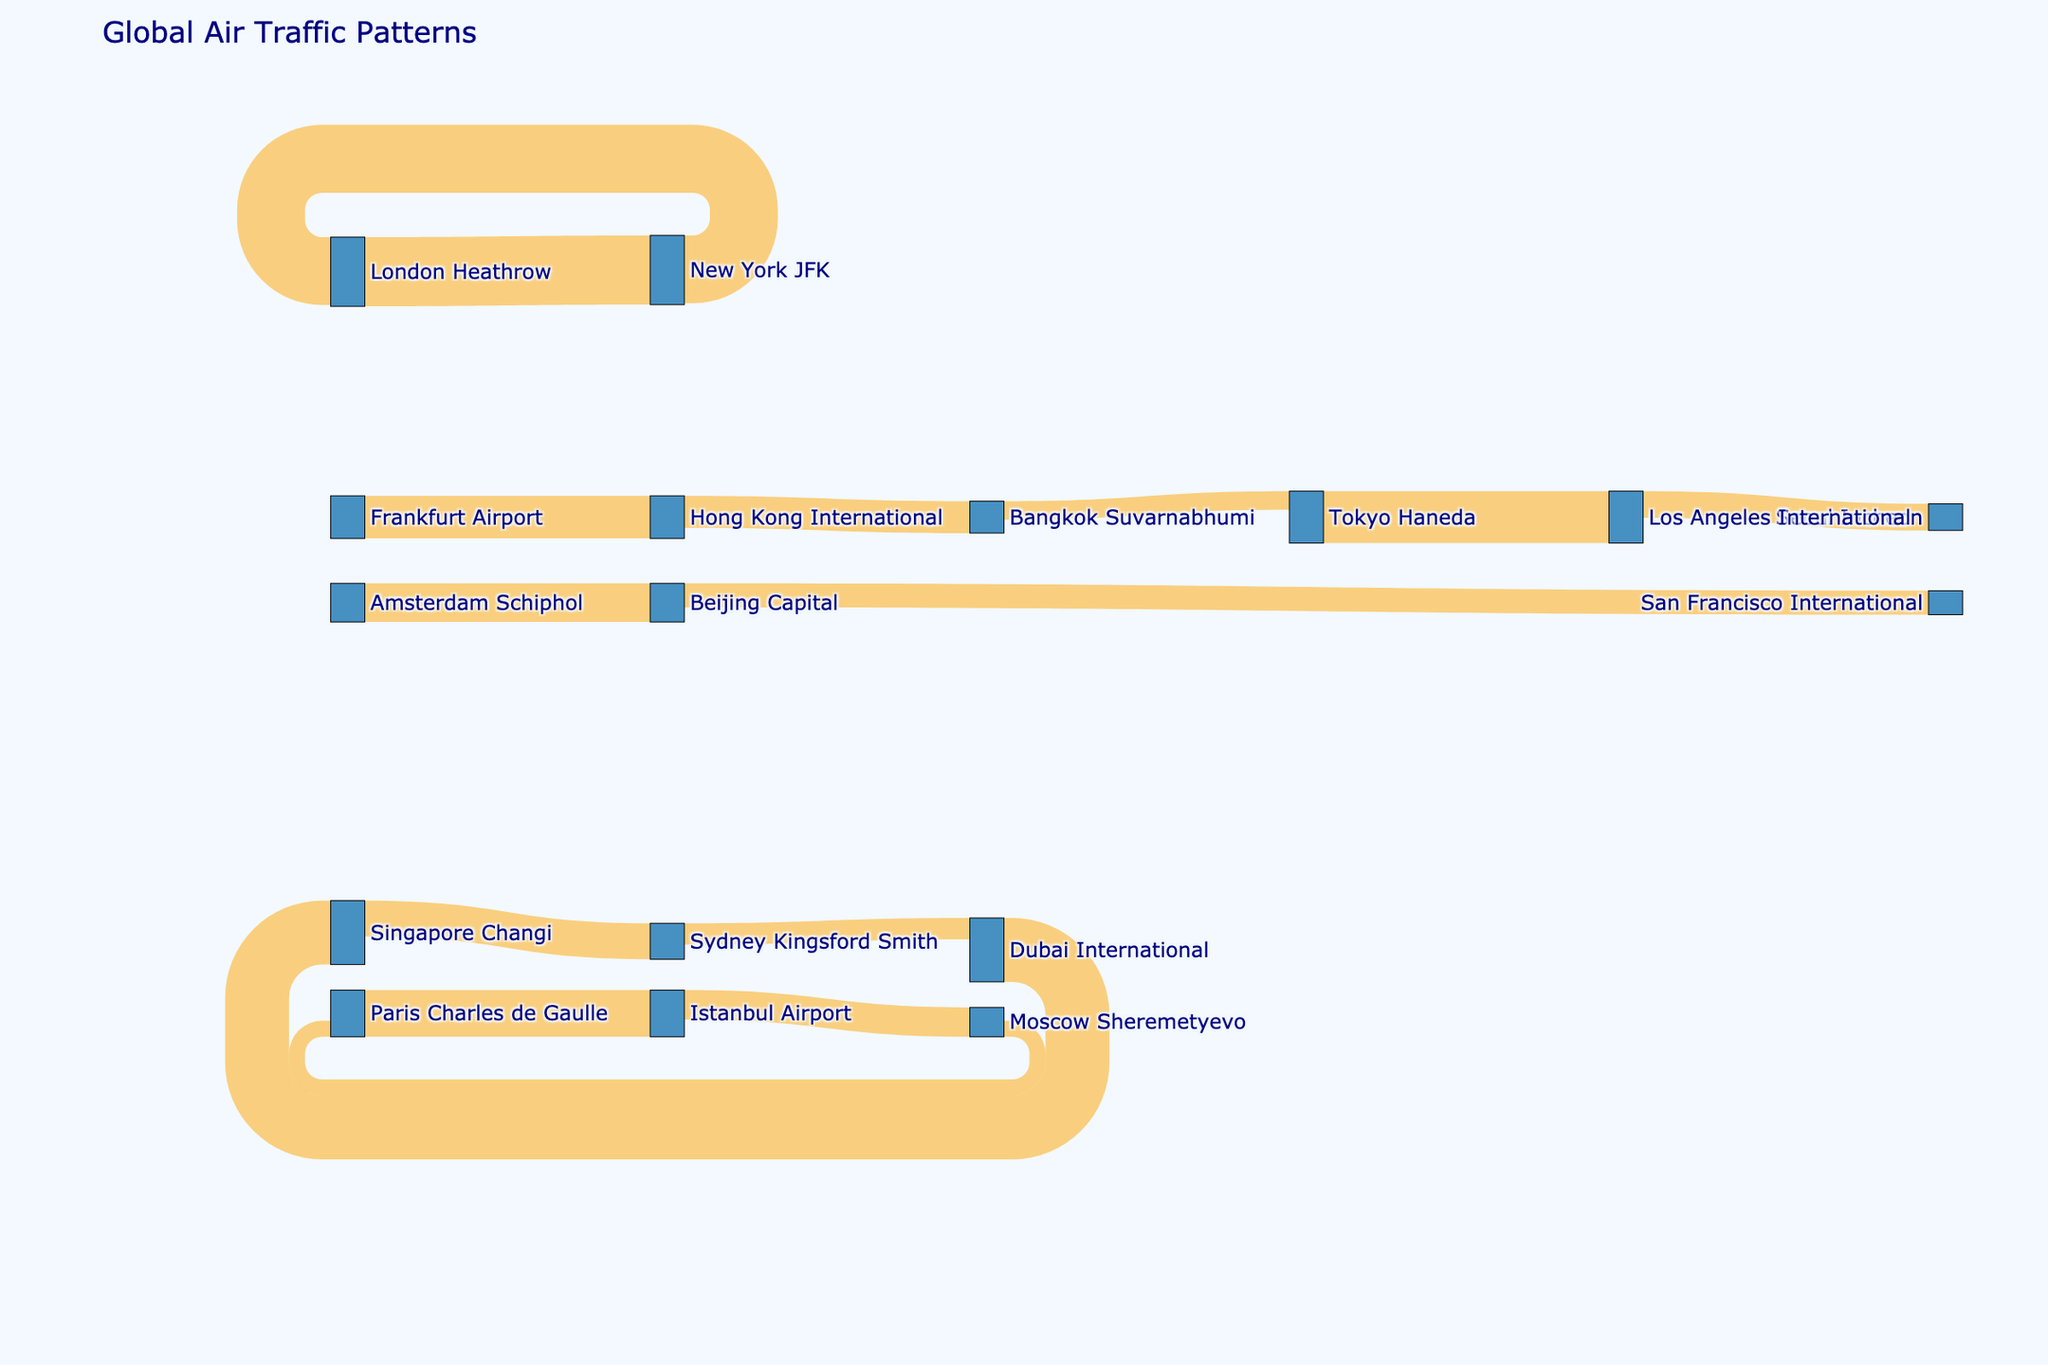what is the title of the figure? The title of the figure is located at the top and indicates the overall topic of the diagram. It provides context to what the visual representation is about.
Answer: Global Air Traffic Patterns How many air routes are depicted in the figure? Each line between nodes represents a route. By counting the lines, we can determine the number of different air routes illustrated in the diagram.
Answer: 15 Which route shows the highest passenger flow? The width of the lines in a Sankey diagram corresponds to the value being represented. The thickest line indicates the route with the highest passenger flow.
Answer: London Heathrow to New York JFK Is there any route where the passenger flow between two airports is bidirectional? Bidirectional flow means there are links going both ways between the same pair of nodes. Look for lines between the same pair of airports going in opposite directions.
Answer: London Heathrow and New York JFK How many airports are depicted in the figure overall? Each node represents an airport. By counting all unique nodes in the diagram, we can determine the number of different airports involved.
Answer: 15 Compare the passenger flow between 'Singapore Changi' to 'Sydney Kingsford Smith' and 'Dubai International' to 'Singapore Changi'. Which one has a higher flow? By comparing the width of the lines connecting the respective pairs of airports, we observe that the thicker line represents the higher flow.
Answer: Dubai International to Singapore Changi What is the combined passenger flow from all routes originating at 'Paris Charles de Gaulle'? Identify the node for 'Paris Charles de Gaulle' and sum the values of all outgoing lines. The value of each route is provided in the visual. (3500000 for 'Paris Charles de Gaulle' to 'Istanbul Airport')
Answer: 3500000 Between 'Tokyo Haneda' to 'Los Angeles International' and 'Bangkok Suvarnabhumi' to 'Tokyo Haneda', which route has a lower passenger flow? By comparing the values represented by the width of the lines, we can determine which route has a lower flow.
Answer: Bangkok Suvarnabhumi to Tokyo Haneda Which airports have both incoming and outgoing flows? Identify nodes that have lines flowing both into and out of them. These airports are involved in bidirectional passenger flows.
Answer: London Heathrow, New York JFK, Singapore Changi, Hong Kong International, Istanbul Airport, Paris Charles de Gaulle, Tokyo Haneda, Bangkok Suvarnabhumi How does the passenger flow from 'Beijing Capital' to 'San Francisco International' compare to the flow from 'Beijing Capital' to 'Amsterdam Schiphol'? By comparing the values represented by the width of the lines, we can see that 'Beijing Capital' to 'San Francisco International' has a lower flow.
Answer: Lower 